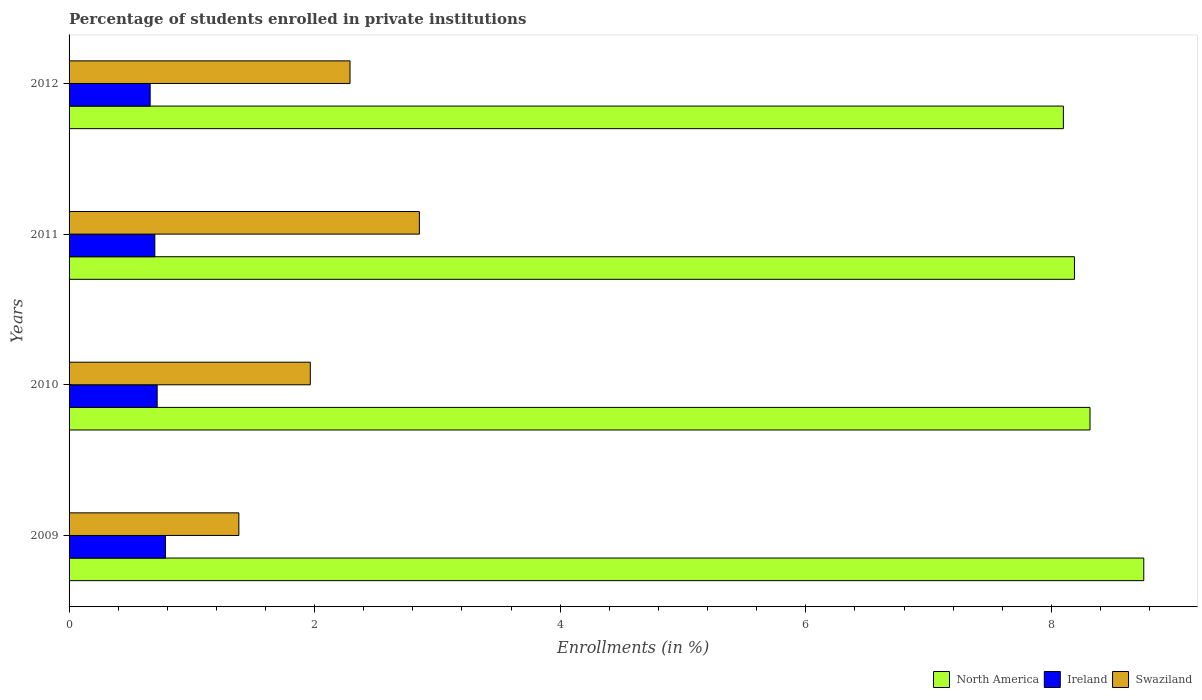How many different coloured bars are there?
Make the answer very short. 3. How many groups of bars are there?
Offer a terse response. 4. Are the number of bars per tick equal to the number of legend labels?
Provide a short and direct response. Yes. How many bars are there on the 2nd tick from the bottom?
Ensure brevity in your answer.  3. In how many cases, is the number of bars for a given year not equal to the number of legend labels?
Give a very brief answer. 0. What is the percentage of trained teachers in Swaziland in 2010?
Make the answer very short. 1.96. Across all years, what is the maximum percentage of trained teachers in Swaziland?
Provide a succinct answer. 2.85. Across all years, what is the minimum percentage of trained teachers in Swaziland?
Make the answer very short. 1.38. In which year was the percentage of trained teachers in Swaziland maximum?
Offer a terse response. 2011. In which year was the percentage of trained teachers in North America minimum?
Your answer should be compact. 2012. What is the total percentage of trained teachers in North America in the graph?
Ensure brevity in your answer.  33.35. What is the difference between the percentage of trained teachers in Ireland in 2009 and that in 2012?
Offer a terse response. 0.12. What is the difference between the percentage of trained teachers in Ireland in 2010 and the percentage of trained teachers in North America in 2009?
Give a very brief answer. -8.04. What is the average percentage of trained teachers in Swaziland per year?
Your answer should be compact. 2.12. In the year 2011, what is the difference between the percentage of trained teachers in North America and percentage of trained teachers in Swaziland?
Offer a very short reply. 5.34. In how many years, is the percentage of trained teachers in North America greater than 0.8 %?
Offer a terse response. 4. What is the ratio of the percentage of trained teachers in Swaziland in 2009 to that in 2012?
Ensure brevity in your answer.  0.6. What is the difference between the highest and the second highest percentage of trained teachers in North America?
Your response must be concise. 0.44. What is the difference between the highest and the lowest percentage of trained teachers in Swaziland?
Provide a succinct answer. 1.47. Is the sum of the percentage of trained teachers in Swaziland in 2009 and 2010 greater than the maximum percentage of trained teachers in Ireland across all years?
Ensure brevity in your answer.  Yes. What does the 1st bar from the top in 2009 represents?
Your answer should be very brief. Swaziland. What does the 2nd bar from the bottom in 2010 represents?
Give a very brief answer. Ireland. What is the difference between two consecutive major ticks on the X-axis?
Keep it short and to the point. 2. What is the title of the graph?
Give a very brief answer. Percentage of students enrolled in private institutions. What is the label or title of the X-axis?
Provide a succinct answer. Enrollments (in %). What is the Enrollments (in %) in North America in 2009?
Ensure brevity in your answer.  8.75. What is the Enrollments (in %) of Ireland in 2009?
Give a very brief answer. 0.79. What is the Enrollments (in %) of Swaziland in 2009?
Provide a succinct answer. 1.38. What is the Enrollments (in %) of North America in 2010?
Your answer should be compact. 8.32. What is the Enrollments (in %) of Ireland in 2010?
Offer a terse response. 0.72. What is the Enrollments (in %) of Swaziland in 2010?
Your response must be concise. 1.96. What is the Enrollments (in %) in North America in 2011?
Keep it short and to the point. 8.19. What is the Enrollments (in %) in Ireland in 2011?
Keep it short and to the point. 0.7. What is the Enrollments (in %) of Swaziland in 2011?
Keep it short and to the point. 2.85. What is the Enrollments (in %) of North America in 2012?
Your answer should be very brief. 8.1. What is the Enrollments (in %) of Ireland in 2012?
Your response must be concise. 0.66. What is the Enrollments (in %) in Swaziland in 2012?
Give a very brief answer. 2.29. Across all years, what is the maximum Enrollments (in %) in North America?
Offer a very short reply. 8.75. Across all years, what is the maximum Enrollments (in %) in Ireland?
Your answer should be very brief. 0.79. Across all years, what is the maximum Enrollments (in %) of Swaziland?
Your response must be concise. 2.85. Across all years, what is the minimum Enrollments (in %) in North America?
Provide a short and direct response. 8.1. Across all years, what is the minimum Enrollments (in %) in Ireland?
Keep it short and to the point. 0.66. Across all years, what is the minimum Enrollments (in %) in Swaziland?
Your answer should be very brief. 1.38. What is the total Enrollments (in %) of North America in the graph?
Keep it short and to the point. 33.35. What is the total Enrollments (in %) of Ireland in the graph?
Ensure brevity in your answer.  2.86. What is the total Enrollments (in %) in Swaziland in the graph?
Your answer should be very brief. 8.49. What is the difference between the Enrollments (in %) in North America in 2009 and that in 2010?
Your response must be concise. 0.44. What is the difference between the Enrollments (in %) in Ireland in 2009 and that in 2010?
Your response must be concise. 0.07. What is the difference between the Enrollments (in %) of Swaziland in 2009 and that in 2010?
Make the answer very short. -0.58. What is the difference between the Enrollments (in %) of North America in 2009 and that in 2011?
Offer a very short reply. 0.56. What is the difference between the Enrollments (in %) of Ireland in 2009 and that in 2011?
Offer a terse response. 0.09. What is the difference between the Enrollments (in %) in Swaziland in 2009 and that in 2011?
Your answer should be compact. -1.47. What is the difference between the Enrollments (in %) in North America in 2009 and that in 2012?
Give a very brief answer. 0.65. What is the difference between the Enrollments (in %) in Ireland in 2009 and that in 2012?
Your response must be concise. 0.12. What is the difference between the Enrollments (in %) of Swaziland in 2009 and that in 2012?
Provide a short and direct response. -0.91. What is the difference between the Enrollments (in %) of North America in 2010 and that in 2011?
Your answer should be compact. 0.13. What is the difference between the Enrollments (in %) of Ireland in 2010 and that in 2011?
Keep it short and to the point. 0.02. What is the difference between the Enrollments (in %) in Swaziland in 2010 and that in 2011?
Your answer should be very brief. -0.89. What is the difference between the Enrollments (in %) in North America in 2010 and that in 2012?
Provide a succinct answer. 0.22. What is the difference between the Enrollments (in %) in Ireland in 2010 and that in 2012?
Your response must be concise. 0.06. What is the difference between the Enrollments (in %) in Swaziland in 2010 and that in 2012?
Your response must be concise. -0.32. What is the difference between the Enrollments (in %) in North America in 2011 and that in 2012?
Offer a very short reply. 0.09. What is the difference between the Enrollments (in %) of Ireland in 2011 and that in 2012?
Provide a succinct answer. 0.04. What is the difference between the Enrollments (in %) of Swaziland in 2011 and that in 2012?
Offer a terse response. 0.56. What is the difference between the Enrollments (in %) of North America in 2009 and the Enrollments (in %) of Ireland in 2010?
Your answer should be very brief. 8.04. What is the difference between the Enrollments (in %) of North America in 2009 and the Enrollments (in %) of Swaziland in 2010?
Give a very brief answer. 6.79. What is the difference between the Enrollments (in %) in Ireland in 2009 and the Enrollments (in %) in Swaziland in 2010?
Your answer should be very brief. -1.18. What is the difference between the Enrollments (in %) in North America in 2009 and the Enrollments (in %) in Ireland in 2011?
Make the answer very short. 8.05. What is the difference between the Enrollments (in %) of North America in 2009 and the Enrollments (in %) of Swaziland in 2011?
Keep it short and to the point. 5.9. What is the difference between the Enrollments (in %) of Ireland in 2009 and the Enrollments (in %) of Swaziland in 2011?
Ensure brevity in your answer.  -2.07. What is the difference between the Enrollments (in %) of North America in 2009 and the Enrollments (in %) of Ireland in 2012?
Make the answer very short. 8.09. What is the difference between the Enrollments (in %) in North America in 2009 and the Enrollments (in %) in Swaziland in 2012?
Provide a succinct answer. 6.46. What is the difference between the Enrollments (in %) in Ireland in 2009 and the Enrollments (in %) in Swaziland in 2012?
Offer a very short reply. -1.5. What is the difference between the Enrollments (in %) in North America in 2010 and the Enrollments (in %) in Ireland in 2011?
Provide a short and direct response. 7.62. What is the difference between the Enrollments (in %) of North America in 2010 and the Enrollments (in %) of Swaziland in 2011?
Provide a short and direct response. 5.46. What is the difference between the Enrollments (in %) of Ireland in 2010 and the Enrollments (in %) of Swaziland in 2011?
Keep it short and to the point. -2.14. What is the difference between the Enrollments (in %) of North America in 2010 and the Enrollments (in %) of Ireland in 2012?
Provide a short and direct response. 7.65. What is the difference between the Enrollments (in %) of North America in 2010 and the Enrollments (in %) of Swaziland in 2012?
Provide a short and direct response. 6.03. What is the difference between the Enrollments (in %) of Ireland in 2010 and the Enrollments (in %) of Swaziland in 2012?
Make the answer very short. -1.57. What is the difference between the Enrollments (in %) of North America in 2011 and the Enrollments (in %) of Ireland in 2012?
Offer a terse response. 7.53. What is the difference between the Enrollments (in %) of North America in 2011 and the Enrollments (in %) of Swaziland in 2012?
Make the answer very short. 5.9. What is the difference between the Enrollments (in %) of Ireland in 2011 and the Enrollments (in %) of Swaziland in 2012?
Your answer should be compact. -1.59. What is the average Enrollments (in %) of North America per year?
Offer a very short reply. 8.34. What is the average Enrollments (in %) in Ireland per year?
Provide a short and direct response. 0.72. What is the average Enrollments (in %) in Swaziland per year?
Offer a terse response. 2.12. In the year 2009, what is the difference between the Enrollments (in %) of North America and Enrollments (in %) of Ireland?
Your response must be concise. 7.97. In the year 2009, what is the difference between the Enrollments (in %) in North America and Enrollments (in %) in Swaziland?
Offer a very short reply. 7.37. In the year 2009, what is the difference between the Enrollments (in %) of Ireland and Enrollments (in %) of Swaziland?
Provide a short and direct response. -0.6. In the year 2010, what is the difference between the Enrollments (in %) of North America and Enrollments (in %) of Ireland?
Ensure brevity in your answer.  7.6. In the year 2010, what is the difference between the Enrollments (in %) in North America and Enrollments (in %) in Swaziland?
Make the answer very short. 6.35. In the year 2010, what is the difference between the Enrollments (in %) in Ireland and Enrollments (in %) in Swaziland?
Provide a short and direct response. -1.25. In the year 2011, what is the difference between the Enrollments (in %) in North America and Enrollments (in %) in Ireland?
Your response must be concise. 7.49. In the year 2011, what is the difference between the Enrollments (in %) in North America and Enrollments (in %) in Swaziland?
Provide a succinct answer. 5.34. In the year 2011, what is the difference between the Enrollments (in %) in Ireland and Enrollments (in %) in Swaziland?
Keep it short and to the point. -2.15. In the year 2012, what is the difference between the Enrollments (in %) of North America and Enrollments (in %) of Ireland?
Offer a terse response. 7.44. In the year 2012, what is the difference between the Enrollments (in %) of North America and Enrollments (in %) of Swaziland?
Provide a short and direct response. 5.81. In the year 2012, what is the difference between the Enrollments (in %) of Ireland and Enrollments (in %) of Swaziland?
Make the answer very short. -1.63. What is the ratio of the Enrollments (in %) of North America in 2009 to that in 2010?
Provide a short and direct response. 1.05. What is the ratio of the Enrollments (in %) of Ireland in 2009 to that in 2010?
Your response must be concise. 1.09. What is the ratio of the Enrollments (in %) of Swaziland in 2009 to that in 2010?
Offer a terse response. 0.7. What is the ratio of the Enrollments (in %) in North America in 2009 to that in 2011?
Offer a terse response. 1.07. What is the ratio of the Enrollments (in %) in Ireland in 2009 to that in 2011?
Provide a short and direct response. 1.12. What is the ratio of the Enrollments (in %) of Swaziland in 2009 to that in 2011?
Offer a very short reply. 0.48. What is the ratio of the Enrollments (in %) of North America in 2009 to that in 2012?
Offer a very short reply. 1.08. What is the ratio of the Enrollments (in %) in Ireland in 2009 to that in 2012?
Your answer should be compact. 1.19. What is the ratio of the Enrollments (in %) in Swaziland in 2009 to that in 2012?
Your response must be concise. 0.6. What is the ratio of the Enrollments (in %) in North America in 2010 to that in 2011?
Offer a terse response. 1.02. What is the ratio of the Enrollments (in %) of Ireland in 2010 to that in 2011?
Your response must be concise. 1.03. What is the ratio of the Enrollments (in %) in Swaziland in 2010 to that in 2011?
Provide a succinct answer. 0.69. What is the ratio of the Enrollments (in %) of North America in 2010 to that in 2012?
Offer a terse response. 1.03. What is the ratio of the Enrollments (in %) of Ireland in 2010 to that in 2012?
Give a very brief answer. 1.09. What is the ratio of the Enrollments (in %) of Swaziland in 2010 to that in 2012?
Offer a very short reply. 0.86. What is the ratio of the Enrollments (in %) of North America in 2011 to that in 2012?
Provide a short and direct response. 1.01. What is the ratio of the Enrollments (in %) of Ireland in 2011 to that in 2012?
Offer a terse response. 1.06. What is the ratio of the Enrollments (in %) of Swaziland in 2011 to that in 2012?
Offer a very short reply. 1.25. What is the difference between the highest and the second highest Enrollments (in %) in North America?
Ensure brevity in your answer.  0.44. What is the difference between the highest and the second highest Enrollments (in %) in Ireland?
Provide a succinct answer. 0.07. What is the difference between the highest and the second highest Enrollments (in %) of Swaziland?
Offer a terse response. 0.56. What is the difference between the highest and the lowest Enrollments (in %) in North America?
Your response must be concise. 0.65. What is the difference between the highest and the lowest Enrollments (in %) of Ireland?
Offer a terse response. 0.12. What is the difference between the highest and the lowest Enrollments (in %) of Swaziland?
Your answer should be compact. 1.47. 